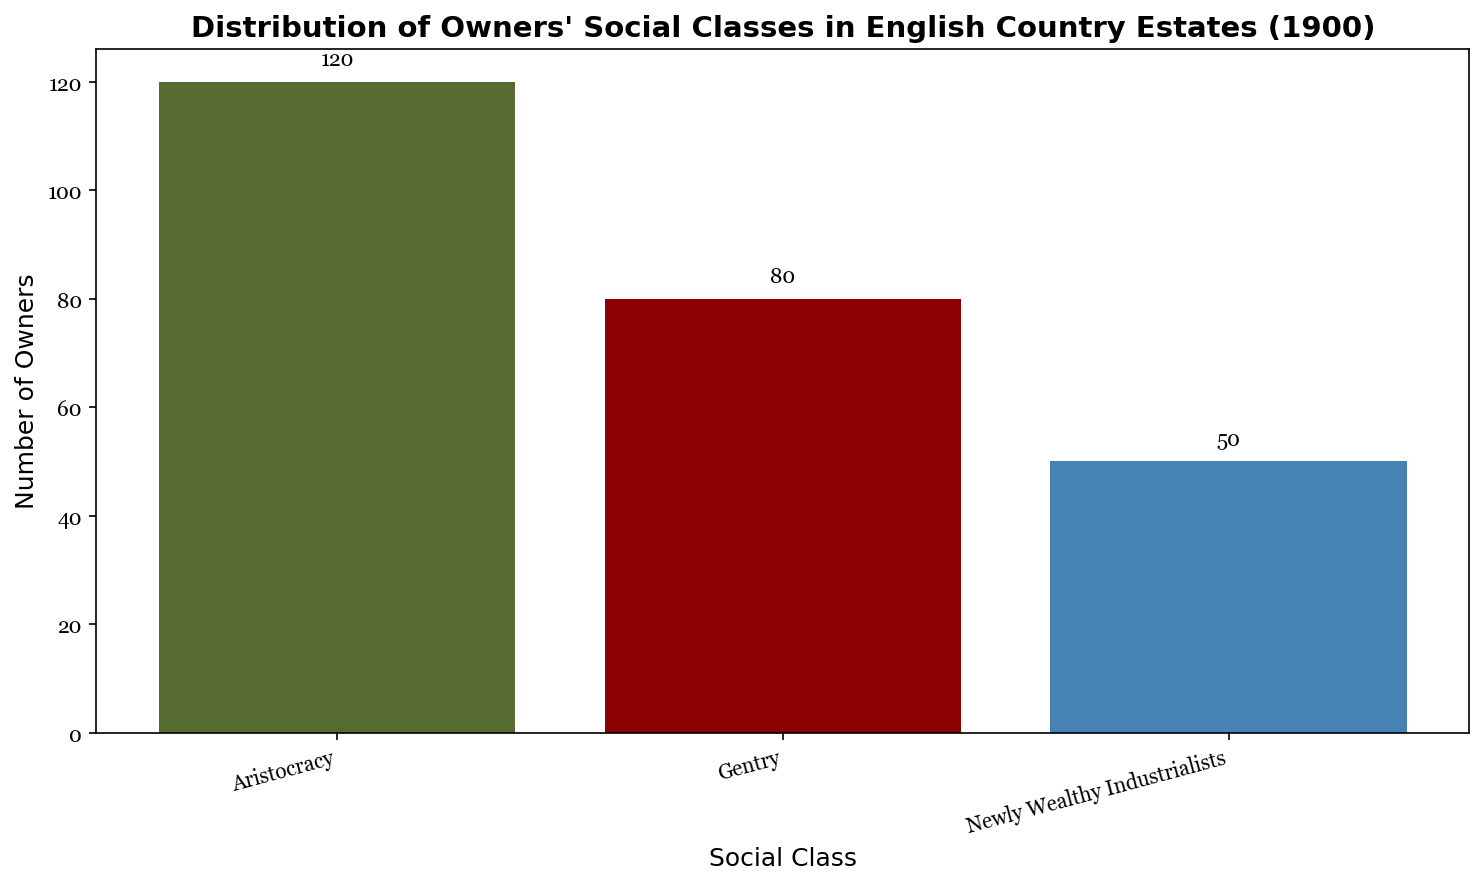What is the total number of estate owners represented in the chart? To find the total number of estate owners, sum the numbers of owners for each social class: 120 (Aristocracy) + 80 (Gentry) + 50 (Newly Wealthy Industrialists) = 250.
Answer: 250 Which social class has the highest number of estate owners? Compare the heights of the bars. The bar for Aristocracy is the tallest, indicating it has the highest number of estate owners (120).
Answer: Aristocracy How many more estate owners are from the Aristocracy compared to the Gentry? Subtract the number of Gentry estate owners (80) from the number of Aristocracy estate owners (120): 120 - 80 = 40.
Answer: 40 What percentage of the total estate owners are Newly Wealthy Industrialists? Calculate the total number of estate owners (250). Then, divide the number of Newly Wealthy Industrialists (50) by the total and multiply by 100 to get the percentage: (50 / 250) * 100 = 20%.
Answer: 20% Are there more Gentry owners than Newly Wealthy Industrialists? Compare the heights of the bars for Gentry and Newly Wealthy Industrialists. The bar for Gentry is taller (80) compared to Newly Wealthy Industrialists (50).
Answer: Yes By how much does the number of Gentry and Newly Wealthy Industrialists' estate owners combined differ from the number of Aristocracy owners? Add the number of Gentry owners (80) to the number of Newly Wealthy Industrialists owners (50): 80 + 50 = 130. Then, subtract this from the number of Aristocracy owners (120): 120 - 130 = -10. Hence, the difference is 10, but in favor of Gentry and Newly Wealthy Industrialists combined.
Answer: 10 Which social class's bar is colored blue? Identify the color associated with each social class. The bar for Newly Wealthy Industrialists is blue.
Answer: Newly Wealthy Industrialists What is the ratio of Aristocracy owners to Newly Wealthy Industrialists? Divide the number of Aristocracy owners (120) by the number of Newly Wealthy Industrialists owners (50): 120 / 50 = 2.4.
Answer: 2.4 If we combine Aristocracy and Gentry owners, what fraction of the total owners do they represent? Calculate the number of Aristocracy and Gentry owners combined: 120 (Aristocracy) + 80 (Gentry) = 200. Then, divide this by the total number of owners (250): 200 / 250 = 4/5 or 0.8.
Answer: 4/5 or 0.8 Which social class has the fewest estate owners? Compare the heights of the bars. The bar for Newly Wealthy Industrialists is the shortest, indicating it has the fewest estate owners (50).
Answer: Newly Wealthy Industrialists 